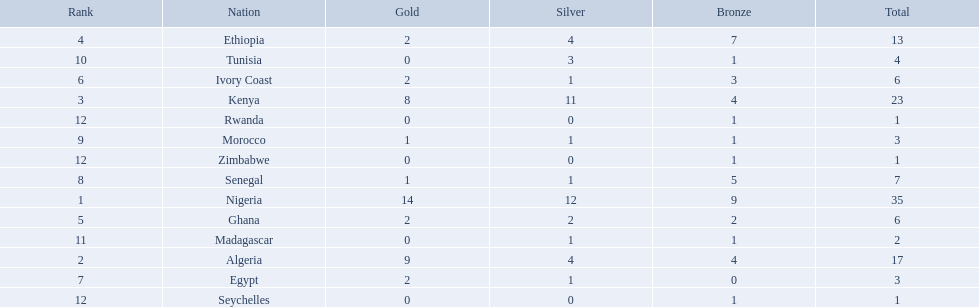Which nations competed in the 1989 african championships in athletics? Nigeria, Algeria, Kenya, Ethiopia, Ghana, Ivory Coast, Egypt, Senegal, Morocco, Tunisia, Madagascar, Rwanda, Zimbabwe, Seychelles. Of these nations, which earned 0 bronze medals? Egypt. 